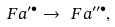Convert formula to latex. <formula><loc_0><loc_0><loc_500><loc_500>\ F a ^ { \prime \bullet } \to \ F a ^ { \prime \prime \bullet } ,</formula> 